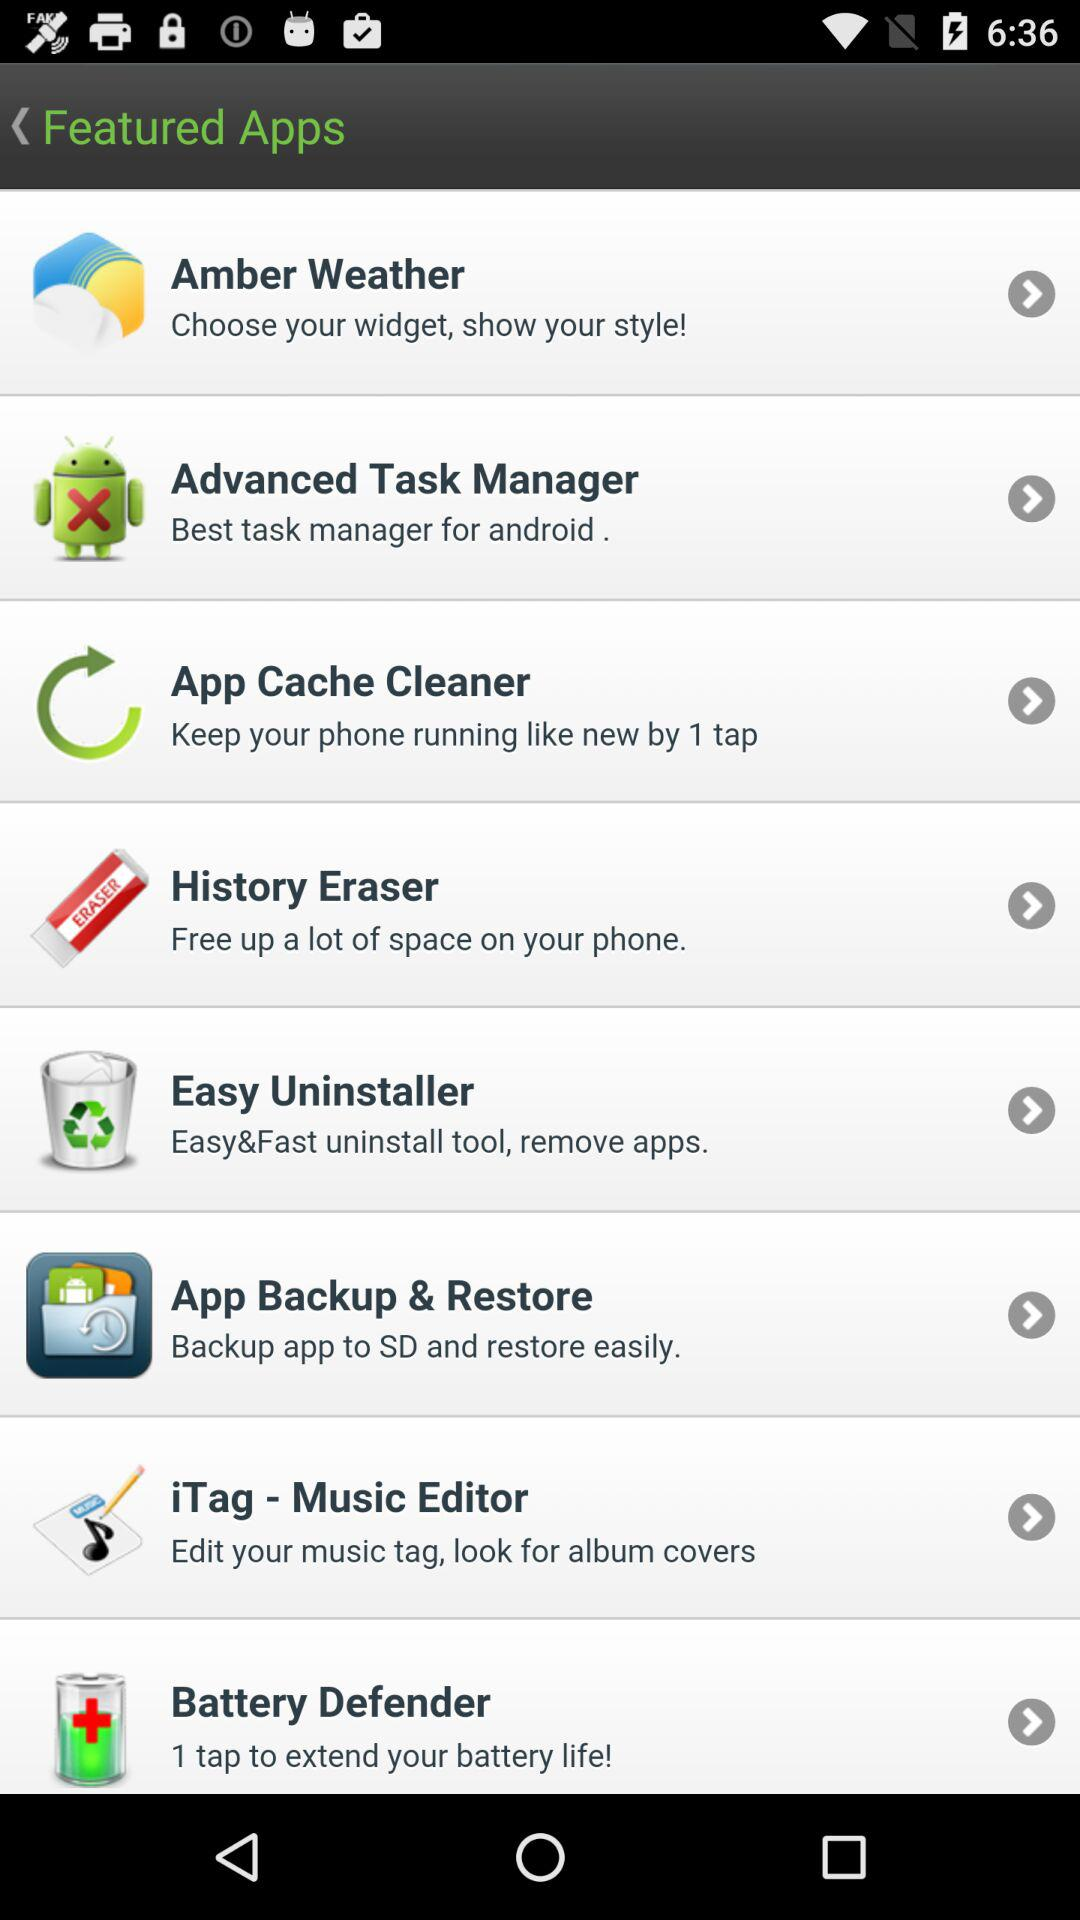What app can we use for "Edit your music tag"? The app is "iTag - Music Editor". 